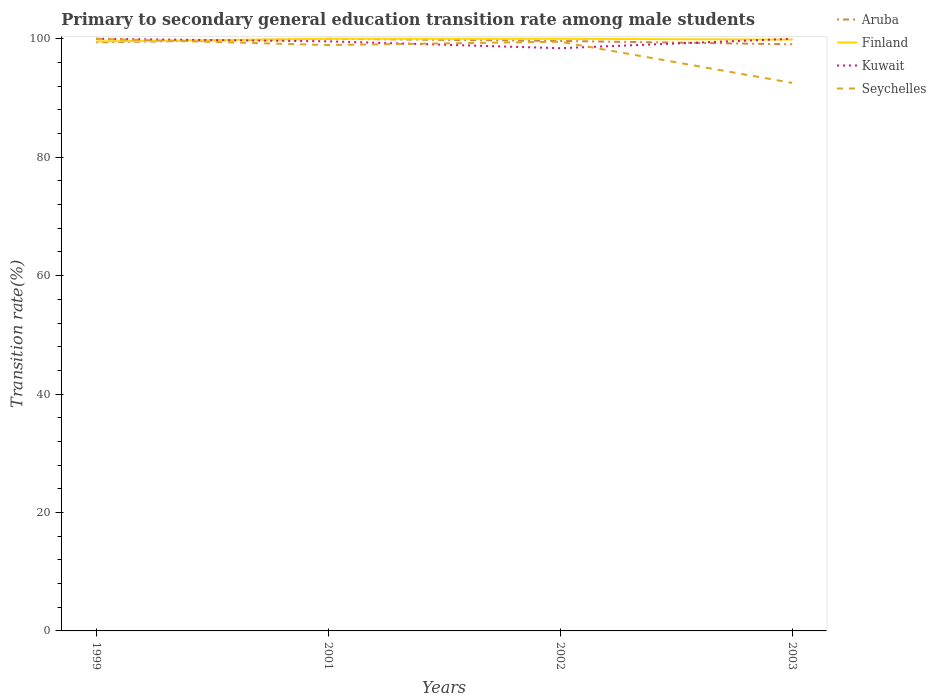Does the line corresponding to Kuwait intersect with the line corresponding to Finland?
Keep it short and to the point. Yes. Across all years, what is the maximum transition rate in Kuwait?
Make the answer very short. 98.41. What is the total transition rate in Finland in the graph?
Offer a very short reply. 0.14. What is the difference between the highest and the second highest transition rate in Kuwait?
Provide a succinct answer. 1.59. Is the transition rate in Aruba strictly greater than the transition rate in Finland over the years?
Your answer should be compact. No. How many years are there in the graph?
Provide a succinct answer. 4. Does the graph contain any zero values?
Your answer should be compact. No. Does the graph contain grids?
Your answer should be compact. No. What is the title of the graph?
Make the answer very short. Primary to secondary general education transition rate among male students. What is the label or title of the Y-axis?
Offer a very short reply. Transition rate(%). What is the Transition rate(%) in Aruba in 1999?
Ensure brevity in your answer.  99.39. What is the Transition rate(%) in Finland in 1999?
Offer a very short reply. 99.56. What is the Transition rate(%) in Kuwait in 1999?
Provide a succinct answer. 100. What is the Transition rate(%) in Seychelles in 1999?
Provide a short and direct response. 100. What is the Transition rate(%) of Aruba in 2001?
Provide a short and direct response. 100. What is the Transition rate(%) in Kuwait in 2001?
Offer a terse response. 99.57. What is the Transition rate(%) in Seychelles in 2001?
Your response must be concise. 98.94. What is the Transition rate(%) in Aruba in 2002?
Give a very brief answer. 99.63. What is the Transition rate(%) in Kuwait in 2002?
Offer a terse response. 98.41. What is the Transition rate(%) in Seychelles in 2002?
Make the answer very short. 99.5. What is the Transition rate(%) in Aruba in 2003?
Keep it short and to the point. 99.07. What is the Transition rate(%) of Finland in 2003?
Your response must be concise. 99.86. What is the Transition rate(%) in Seychelles in 2003?
Keep it short and to the point. 92.55. Across all years, what is the maximum Transition rate(%) in Aruba?
Keep it short and to the point. 100. Across all years, what is the minimum Transition rate(%) of Aruba?
Offer a terse response. 99.07. Across all years, what is the minimum Transition rate(%) of Finland?
Your answer should be compact. 99.56. Across all years, what is the minimum Transition rate(%) of Kuwait?
Provide a succinct answer. 98.41. Across all years, what is the minimum Transition rate(%) in Seychelles?
Give a very brief answer. 92.55. What is the total Transition rate(%) of Aruba in the graph?
Keep it short and to the point. 398.1. What is the total Transition rate(%) of Finland in the graph?
Offer a terse response. 399.42. What is the total Transition rate(%) of Kuwait in the graph?
Your response must be concise. 397.98. What is the total Transition rate(%) in Seychelles in the graph?
Provide a succinct answer. 390.99. What is the difference between the Transition rate(%) in Aruba in 1999 and that in 2001?
Keep it short and to the point. -0.61. What is the difference between the Transition rate(%) of Finland in 1999 and that in 2001?
Offer a very short reply. -0.44. What is the difference between the Transition rate(%) in Kuwait in 1999 and that in 2001?
Provide a short and direct response. 0.43. What is the difference between the Transition rate(%) of Seychelles in 1999 and that in 2001?
Keep it short and to the point. 1.06. What is the difference between the Transition rate(%) of Aruba in 1999 and that in 2002?
Ensure brevity in your answer.  -0.24. What is the difference between the Transition rate(%) of Finland in 1999 and that in 2002?
Offer a very short reply. -0.44. What is the difference between the Transition rate(%) in Kuwait in 1999 and that in 2002?
Your response must be concise. 1.59. What is the difference between the Transition rate(%) in Seychelles in 1999 and that in 2002?
Keep it short and to the point. 0.5. What is the difference between the Transition rate(%) in Aruba in 1999 and that in 2003?
Make the answer very short. 0.32. What is the difference between the Transition rate(%) in Finland in 1999 and that in 2003?
Your answer should be compact. -0.3. What is the difference between the Transition rate(%) of Kuwait in 1999 and that in 2003?
Keep it short and to the point. 0. What is the difference between the Transition rate(%) of Seychelles in 1999 and that in 2003?
Your answer should be compact. 7.45. What is the difference between the Transition rate(%) of Aruba in 2001 and that in 2002?
Make the answer very short. 0.37. What is the difference between the Transition rate(%) of Finland in 2001 and that in 2002?
Give a very brief answer. 0. What is the difference between the Transition rate(%) in Kuwait in 2001 and that in 2002?
Provide a short and direct response. 1.16. What is the difference between the Transition rate(%) of Seychelles in 2001 and that in 2002?
Offer a terse response. -0.56. What is the difference between the Transition rate(%) in Finland in 2001 and that in 2003?
Keep it short and to the point. 0.14. What is the difference between the Transition rate(%) of Kuwait in 2001 and that in 2003?
Your answer should be compact. -0.43. What is the difference between the Transition rate(%) in Seychelles in 2001 and that in 2003?
Provide a short and direct response. 6.39. What is the difference between the Transition rate(%) of Aruba in 2002 and that in 2003?
Your answer should be compact. 0.56. What is the difference between the Transition rate(%) in Finland in 2002 and that in 2003?
Your answer should be compact. 0.14. What is the difference between the Transition rate(%) of Kuwait in 2002 and that in 2003?
Ensure brevity in your answer.  -1.59. What is the difference between the Transition rate(%) of Seychelles in 2002 and that in 2003?
Ensure brevity in your answer.  6.95. What is the difference between the Transition rate(%) in Aruba in 1999 and the Transition rate(%) in Finland in 2001?
Make the answer very short. -0.61. What is the difference between the Transition rate(%) in Aruba in 1999 and the Transition rate(%) in Kuwait in 2001?
Provide a succinct answer. -0.18. What is the difference between the Transition rate(%) in Aruba in 1999 and the Transition rate(%) in Seychelles in 2001?
Provide a short and direct response. 0.45. What is the difference between the Transition rate(%) of Finland in 1999 and the Transition rate(%) of Kuwait in 2001?
Keep it short and to the point. -0.01. What is the difference between the Transition rate(%) in Finland in 1999 and the Transition rate(%) in Seychelles in 2001?
Provide a succinct answer. 0.61. What is the difference between the Transition rate(%) of Kuwait in 1999 and the Transition rate(%) of Seychelles in 2001?
Offer a terse response. 1.06. What is the difference between the Transition rate(%) of Aruba in 1999 and the Transition rate(%) of Finland in 2002?
Offer a terse response. -0.61. What is the difference between the Transition rate(%) in Aruba in 1999 and the Transition rate(%) in Kuwait in 2002?
Your response must be concise. 0.98. What is the difference between the Transition rate(%) in Aruba in 1999 and the Transition rate(%) in Seychelles in 2002?
Ensure brevity in your answer.  -0.11. What is the difference between the Transition rate(%) in Finland in 1999 and the Transition rate(%) in Kuwait in 2002?
Make the answer very short. 1.14. What is the difference between the Transition rate(%) in Finland in 1999 and the Transition rate(%) in Seychelles in 2002?
Provide a succinct answer. 0.06. What is the difference between the Transition rate(%) in Kuwait in 1999 and the Transition rate(%) in Seychelles in 2002?
Give a very brief answer. 0.5. What is the difference between the Transition rate(%) of Aruba in 1999 and the Transition rate(%) of Finland in 2003?
Ensure brevity in your answer.  -0.47. What is the difference between the Transition rate(%) of Aruba in 1999 and the Transition rate(%) of Kuwait in 2003?
Your answer should be very brief. -0.61. What is the difference between the Transition rate(%) of Aruba in 1999 and the Transition rate(%) of Seychelles in 2003?
Make the answer very short. 6.84. What is the difference between the Transition rate(%) in Finland in 1999 and the Transition rate(%) in Kuwait in 2003?
Offer a very short reply. -0.44. What is the difference between the Transition rate(%) in Finland in 1999 and the Transition rate(%) in Seychelles in 2003?
Your answer should be compact. 7.01. What is the difference between the Transition rate(%) in Kuwait in 1999 and the Transition rate(%) in Seychelles in 2003?
Provide a short and direct response. 7.45. What is the difference between the Transition rate(%) in Aruba in 2001 and the Transition rate(%) in Finland in 2002?
Ensure brevity in your answer.  0. What is the difference between the Transition rate(%) of Aruba in 2001 and the Transition rate(%) of Kuwait in 2002?
Give a very brief answer. 1.59. What is the difference between the Transition rate(%) of Aruba in 2001 and the Transition rate(%) of Seychelles in 2002?
Give a very brief answer. 0.5. What is the difference between the Transition rate(%) of Finland in 2001 and the Transition rate(%) of Kuwait in 2002?
Make the answer very short. 1.59. What is the difference between the Transition rate(%) in Finland in 2001 and the Transition rate(%) in Seychelles in 2002?
Your answer should be compact. 0.5. What is the difference between the Transition rate(%) of Kuwait in 2001 and the Transition rate(%) of Seychelles in 2002?
Your response must be concise. 0.07. What is the difference between the Transition rate(%) in Aruba in 2001 and the Transition rate(%) in Finland in 2003?
Keep it short and to the point. 0.14. What is the difference between the Transition rate(%) of Aruba in 2001 and the Transition rate(%) of Seychelles in 2003?
Give a very brief answer. 7.45. What is the difference between the Transition rate(%) in Finland in 2001 and the Transition rate(%) in Seychelles in 2003?
Offer a terse response. 7.45. What is the difference between the Transition rate(%) of Kuwait in 2001 and the Transition rate(%) of Seychelles in 2003?
Provide a short and direct response. 7.02. What is the difference between the Transition rate(%) of Aruba in 2002 and the Transition rate(%) of Finland in 2003?
Offer a terse response. -0.23. What is the difference between the Transition rate(%) in Aruba in 2002 and the Transition rate(%) in Kuwait in 2003?
Ensure brevity in your answer.  -0.37. What is the difference between the Transition rate(%) in Aruba in 2002 and the Transition rate(%) in Seychelles in 2003?
Your answer should be very brief. 7.09. What is the difference between the Transition rate(%) of Finland in 2002 and the Transition rate(%) of Kuwait in 2003?
Your answer should be compact. 0. What is the difference between the Transition rate(%) of Finland in 2002 and the Transition rate(%) of Seychelles in 2003?
Offer a very short reply. 7.45. What is the difference between the Transition rate(%) of Kuwait in 2002 and the Transition rate(%) of Seychelles in 2003?
Your response must be concise. 5.86. What is the average Transition rate(%) in Aruba per year?
Offer a terse response. 99.52. What is the average Transition rate(%) of Finland per year?
Your answer should be compact. 99.85. What is the average Transition rate(%) of Kuwait per year?
Keep it short and to the point. 99.5. What is the average Transition rate(%) in Seychelles per year?
Provide a succinct answer. 97.75. In the year 1999, what is the difference between the Transition rate(%) in Aruba and Transition rate(%) in Finland?
Your answer should be compact. -0.16. In the year 1999, what is the difference between the Transition rate(%) in Aruba and Transition rate(%) in Kuwait?
Your answer should be very brief. -0.61. In the year 1999, what is the difference between the Transition rate(%) in Aruba and Transition rate(%) in Seychelles?
Provide a succinct answer. -0.61. In the year 1999, what is the difference between the Transition rate(%) in Finland and Transition rate(%) in Kuwait?
Provide a short and direct response. -0.44. In the year 1999, what is the difference between the Transition rate(%) of Finland and Transition rate(%) of Seychelles?
Ensure brevity in your answer.  -0.44. In the year 2001, what is the difference between the Transition rate(%) of Aruba and Transition rate(%) of Kuwait?
Make the answer very short. 0.43. In the year 2001, what is the difference between the Transition rate(%) of Aruba and Transition rate(%) of Seychelles?
Provide a succinct answer. 1.06. In the year 2001, what is the difference between the Transition rate(%) of Finland and Transition rate(%) of Kuwait?
Provide a short and direct response. 0.43. In the year 2001, what is the difference between the Transition rate(%) of Finland and Transition rate(%) of Seychelles?
Your response must be concise. 1.06. In the year 2001, what is the difference between the Transition rate(%) in Kuwait and Transition rate(%) in Seychelles?
Ensure brevity in your answer.  0.63. In the year 2002, what is the difference between the Transition rate(%) of Aruba and Transition rate(%) of Finland?
Your answer should be very brief. -0.37. In the year 2002, what is the difference between the Transition rate(%) in Aruba and Transition rate(%) in Kuwait?
Provide a short and direct response. 1.22. In the year 2002, what is the difference between the Transition rate(%) of Aruba and Transition rate(%) of Seychelles?
Provide a succinct answer. 0.13. In the year 2002, what is the difference between the Transition rate(%) in Finland and Transition rate(%) in Kuwait?
Provide a succinct answer. 1.59. In the year 2002, what is the difference between the Transition rate(%) in Finland and Transition rate(%) in Seychelles?
Your answer should be compact. 0.5. In the year 2002, what is the difference between the Transition rate(%) in Kuwait and Transition rate(%) in Seychelles?
Keep it short and to the point. -1.09. In the year 2003, what is the difference between the Transition rate(%) in Aruba and Transition rate(%) in Finland?
Keep it short and to the point. -0.79. In the year 2003, what is the difference between the Transition rate(%) of Aruba and Transition rate(%) of Kuwait?
Give a very brief answer. -0.93. In the year 2003, what is the difference between the Transition rate(%) in Aruba and Transition rate(%) in Seychelles?
Provide a short and direct response. 6.52. In the year 2003, what is the difference between the Transition rate(%) of Finland and Transition rate(%) of Kuwait?
Provide a succinct answer. -0.14. In the year 2003, what is the difference between the Transition rate(%) of Finland and Transition rate(%) of Seychelles?
Give a very brief answer. 7.31. In the year 2003, what is the difference between the Transition rate(%) in Kuwait and Transition rate(%) in Seychelles?
Make the answer very short. 7.45. What is the ratio of the Transition rate(%) of Aruba in 1999 to that in 2001?
Give a very brief answer. 0.99. What is the ratio of the Transition rate(%) of Kuwait in 1999 to that in 2001?
Make the answer very short. 1. What is the ratio of the Transition rate(%) in Seychelles in 1999 to that in 2001?
Keep it short and to the point. 1.01. What is the ratio of the Transition rate(%) in Finland in 1999 to that in 2002?
Give a very brief answer. 1. What is the ratio of the Transition rate(%) of Kuwait in 1999 to that in 2002?
Your answer should be very brief. 1.02. What is the ratio of the Transition rate(%) of Aruba in 1999 to that in 2003?
Your answer should be compact. 1. What is the ratio of the Transition rate(%) of Seychelles in 1999 to that in 2003?
Make the answer very short. 1.08. What is the ratio of the Transition rate(%) of Kuwait in 2001 to that in 2002?
Provide a short and direct response. 1.01. What is the ratio of the Transition rate(%) of Seychelles in 2001 to that in 2002?
Make the answer very short. 0.99. What is the ratio of the Transition rate(%) in Aruba in 2001 to that in 2003?
Ensure brevity in your answer.  1.01. What is the ratio of the Transition rate(%) of Finland in 2001 to that in 2003?
Give a very brief answer. 1. What is the ratio of the Transition rate(%) in Seychelles in 2001 to that in 2003?
Offer a terse response. 1.07. What is the ratio of the Transition rate(%) in Aruba in 2002 to that in 2003?
Make the answer very short. 1.01. What is the ratio of the Transition rate(%) in Kuwait in 2002 to that in 2003?
Provide a succinct answer. 0.98. What is the ratio of the Transition rate(%) of Seychelles in 2002 to that in 2003?
Your response must be concise. 1.08. What is the difference between the highest and the second highest Transition rate(%) in Aruba?
Give a very brief answer. 0.37. What is the difference between the highest and the second highest Transition rate(%) of Seychelles?
Ensure brevity in your answer.  0.5. What is the difference between the highest and the lowest Transition rate(%) of Finland?
Your answer should be very brief. 0.44. What is the difference between the highest and the lowest Transition rate(%) in Kuwait?
Your answer should be compact. 1.59. What is the difference between the highest and the lowest Transition rate(%) of Seychelles?
Offer a very short reply. 7.45. 